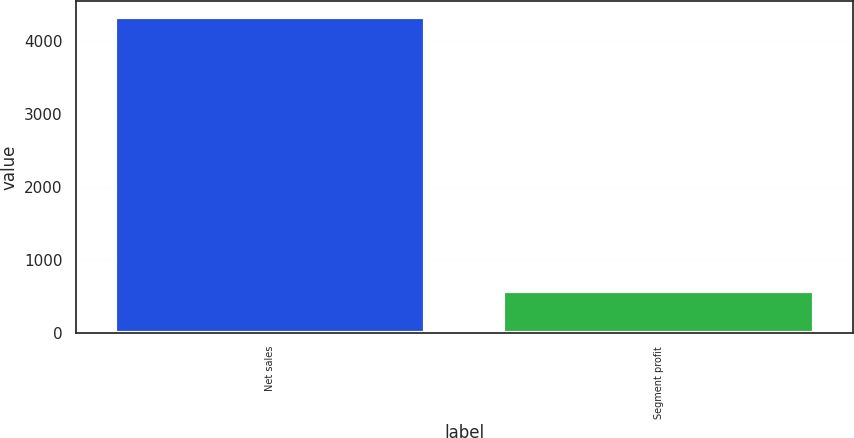Convert chart to OTSL. <chart><loc_0><loc_0><loc_500><loc_500><bar_chart><fcel>Net sales<fcel>Segment profit<nl><fcel>4323<fcel>575<nl></chart> 